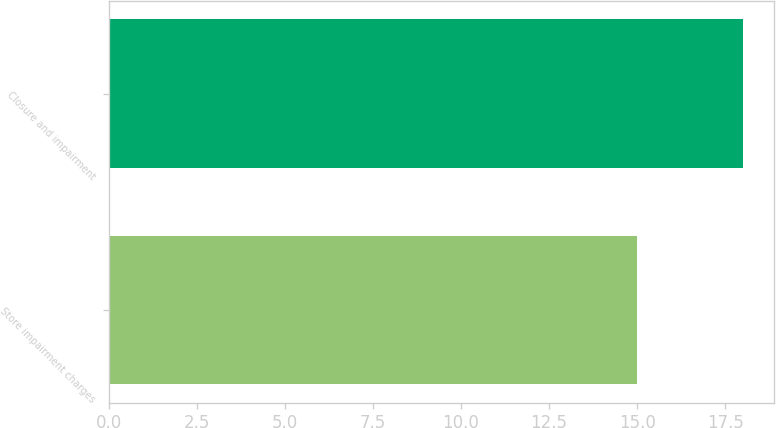<chart> <loc_0><loc_0><loc_500><loc_500><bar_chart><fcel>Store impairment charges<fcel>Closure and impairment<nl><fcel>15<fcel>18<nl></chart> 